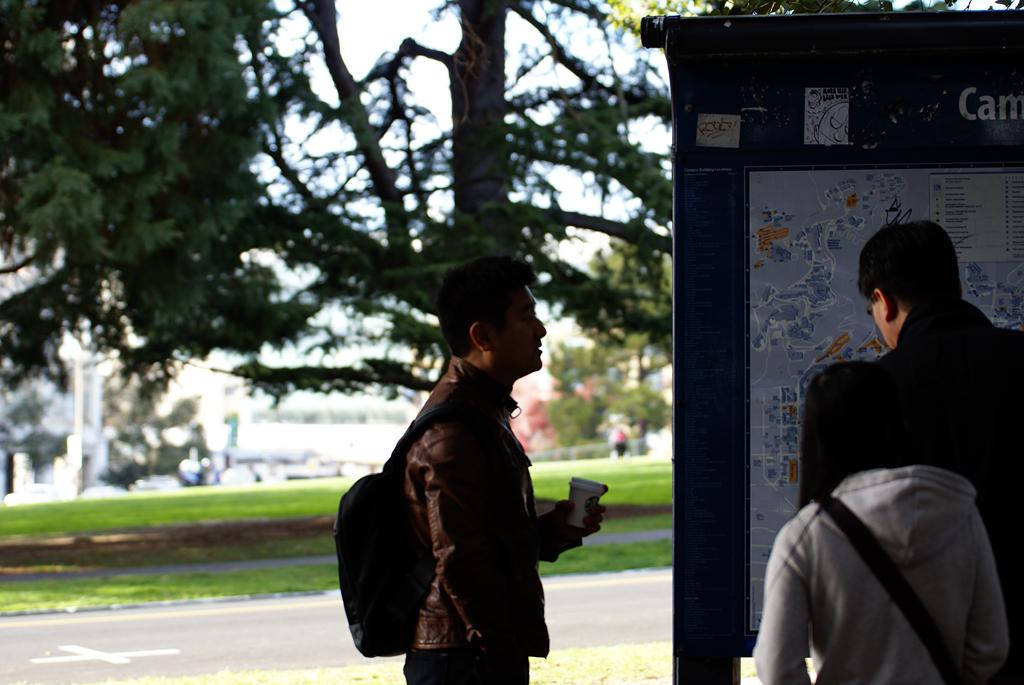Who or what is present in the image? There are people in the image. What object can be seen in the image? There is a board in the image. Can you describe the background of the image? The background of the image is blurry, and it includes trees, grass, and the sky. What type of pipe can be seen in the image? There is no pipe present in the image. How many snakes are visible in the image? There are no snakes visible in the image. 